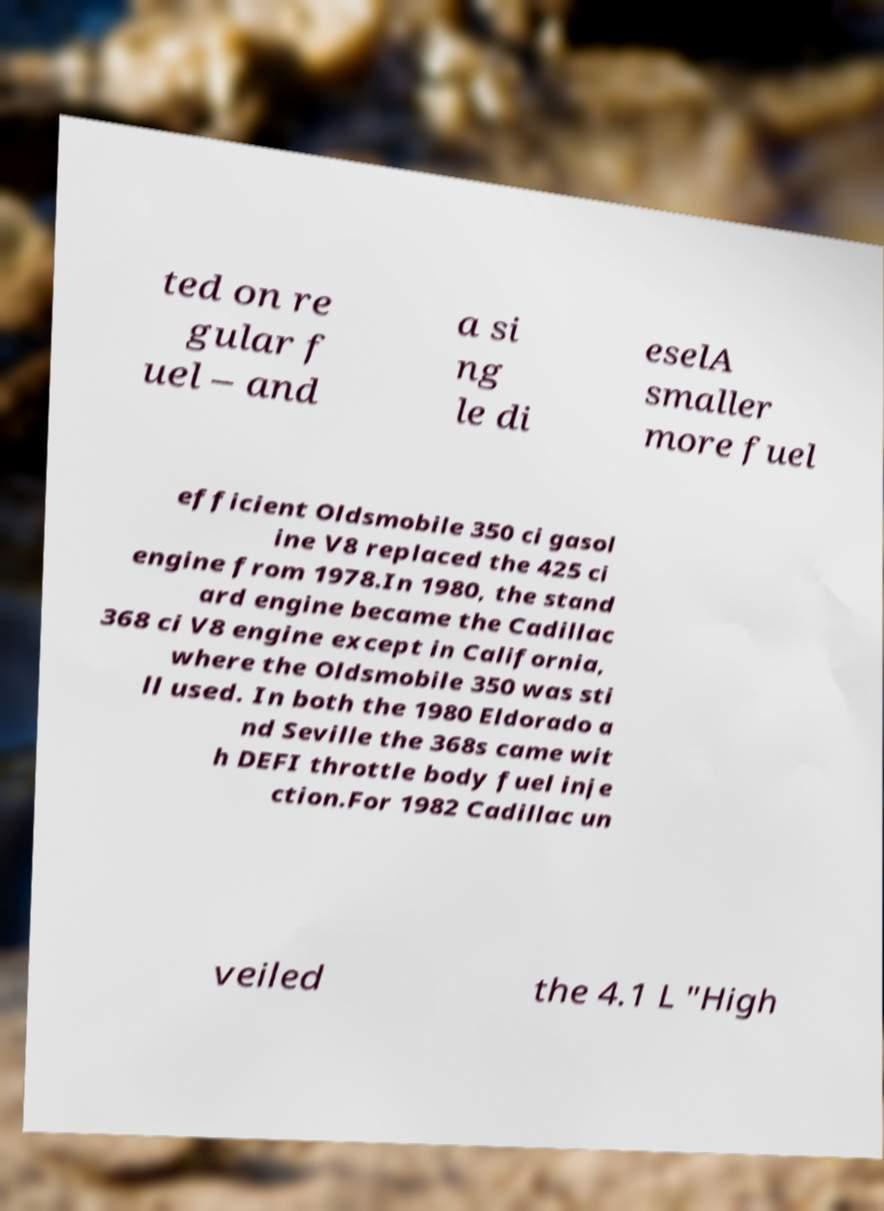I need the written content from this picture converted into text. Can you do that? ted on re gular f uel – and a si ng le di eselA smaller more fuel efficient Oldsmobile 350 ci gasol ine V8 replaced the 425 ci engine from 1978.In 1980, the stand ard engine became the Cadillac 368 ci V8 engine except in California, where the Oldsmobile 350 was sti ll used. In both the 1980 Eldorado a nd Seville the 368s came wit h DEFI throttle body fuel inje ction.For 1982 Cadillac un veiled the 4.1 L "High 